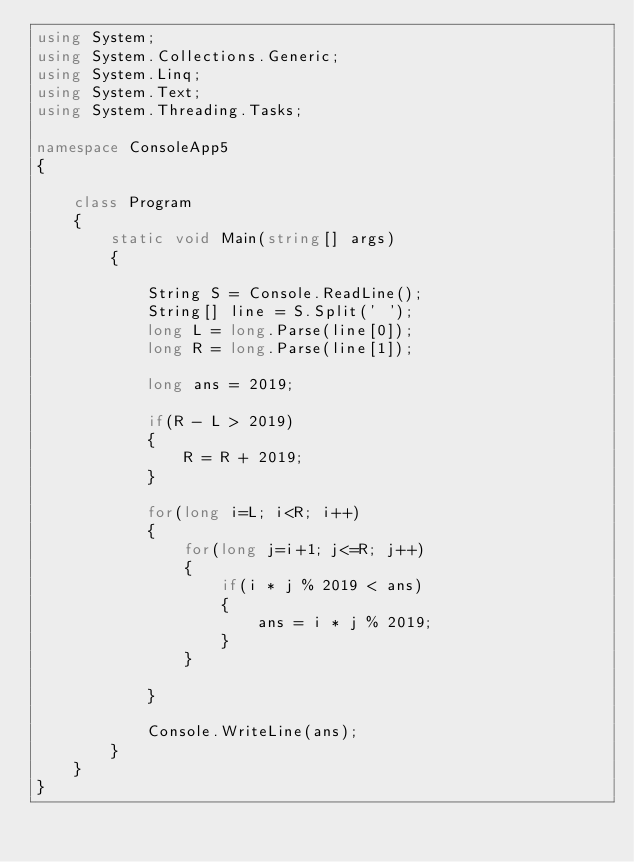Convert code to text. <code><loc_0><loc_0><loc_500><loc_500><_C#_>using System;
using System.Collections.Generic;
using System.Linq;
using System.Text;
using System.Threading.Tasks;

namespace ConsoleApp5
{

    class Program
    {
        static void Main(string[] args)
        {

            String S = Console.ReadLine();
            String[] line = S.Split(' ');
            long L = long.Parse(line[0]);
            long R = long.Parse(line[1]);

            long ans = 2019;
            
            if(R - L > 2019)
            {
                R = R + 2019;
            }

            for(long i=L; i<R; i++)
            {
                for(long j=i+1; j<=R; j++)
                {
                    if(i * j % 2019 < ans)
                    {
                        ans = i * j % 2019;
                    }
                }

            }

            Console.WriteLine(ans);
        }
    }
}</code> 